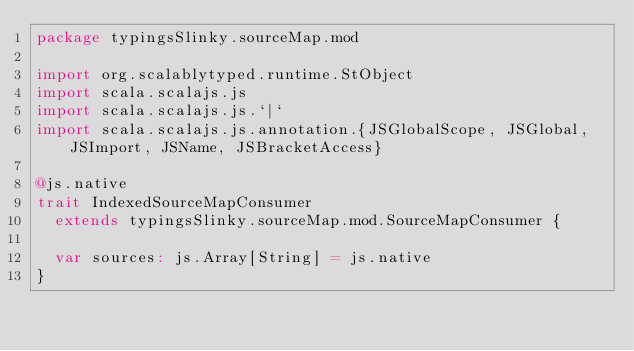Convert code to text. <code><loc_0><loc_0><loc_500><loc_500><_Scala_>package typingsSlinky.sourceMap.mod

import org.scalablytyped.runtime.StObject
import scala.scalajs.js
import scala.scalajs.js.`|`
import scala.scalajs.js.annotation.{JSGlobalScope, JSGlobal, JSImport, JSName, JSBracketAccess}

@js.native
trait IndexedSourceMapConsumer
  extends typingsSlinky.sourceMap.mod.SourceMapConsumer {
  
  var sources: js.Array[String] = js.native
}
</code> 